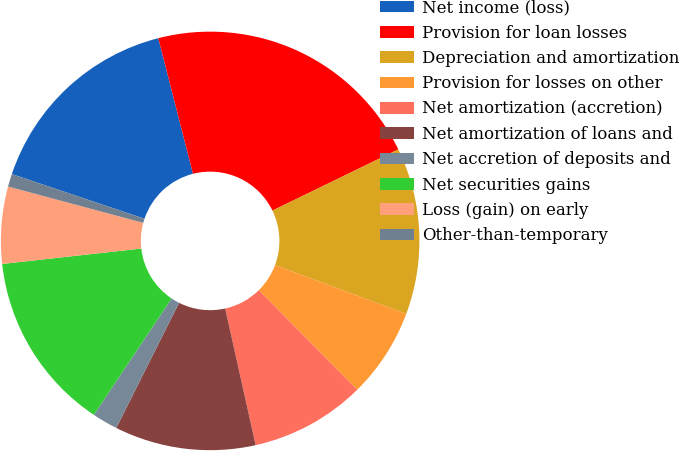Convert chart. <chart><loc_0><loc_0><loc_500><loc_500><pie_chart><fcel>Net income (loss)<fcel>Provision for loan losses<fcel>Depreciation and amortization<fcel>Provision for losses on other<fcel>Net amortization (accretion)<fcel>Net amortization of loans and<fcel>Net accretion of deposits and<fcel>Net securities gains<fcel>Loss (gain) on early<fcel>Other-than-temporary<nl><fcel>15.84%<fcel>21.78%<fcel>12.87%<fcel>6.93%<fcel>8.91%<fcel>10.89%<fcel>1.98%<fcel>13.86%<fcel>5.94%<fcel>0.99%<nl></chart> 